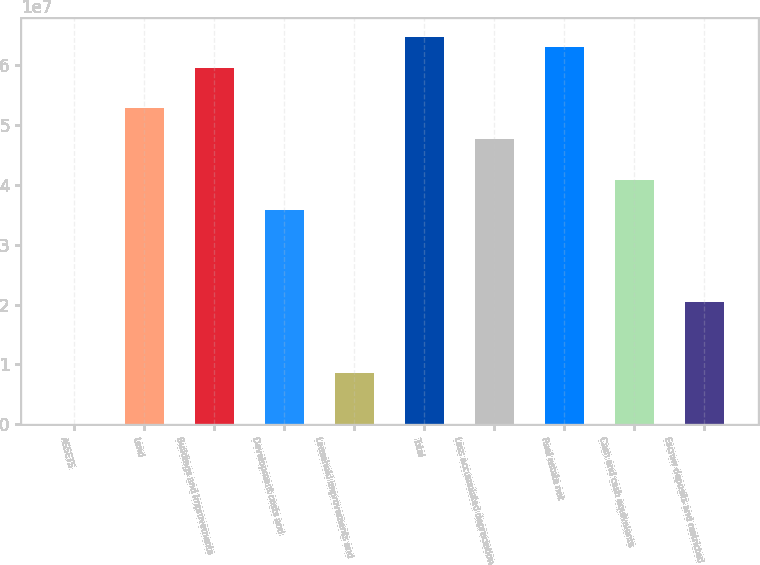Convert chart. <chart><loc_0><loc_0><loc_500><loc_500><bar_chart><fcel>ASSETS<fcel>Land<fcel>Buildings and improvements<fcel>Development costs and<fcel>Leasehold improvements and<fcel>Total<fcel>Less accumulated depreciation<fcel>Real estate net<fcel>Cash and cash equivalents<fcel>Escrow deposits and restricted<nl><fcel>2007<fcel>5.27842e+07<fcel>5.95948e+07<fcel>3.57577e+07<fcel>8.51526e+06<fcel>6.47027e+07<fcel>4.76762e+07<fcel>6.30001e+07<fcel>4.08656e+07<fcel>2.04338e+07<nl></chart> 